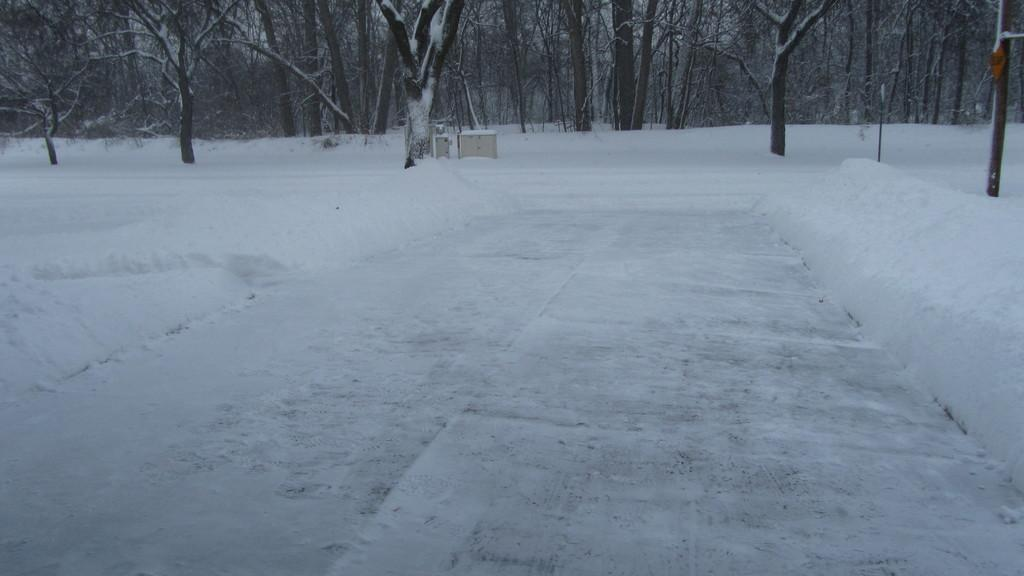What type of vegetation is visible in the image? There are trees in the image. What is covering the ground in the image? There is snow on the ground in the image. How many kittens are hiding in the trees in the image? There are no kittens visible in the image; it only features trees and snow on the ground. What type of fruit is growing on the trees in the image? There is no fruit visible on the trees in the image; only the trees themselves are present. 